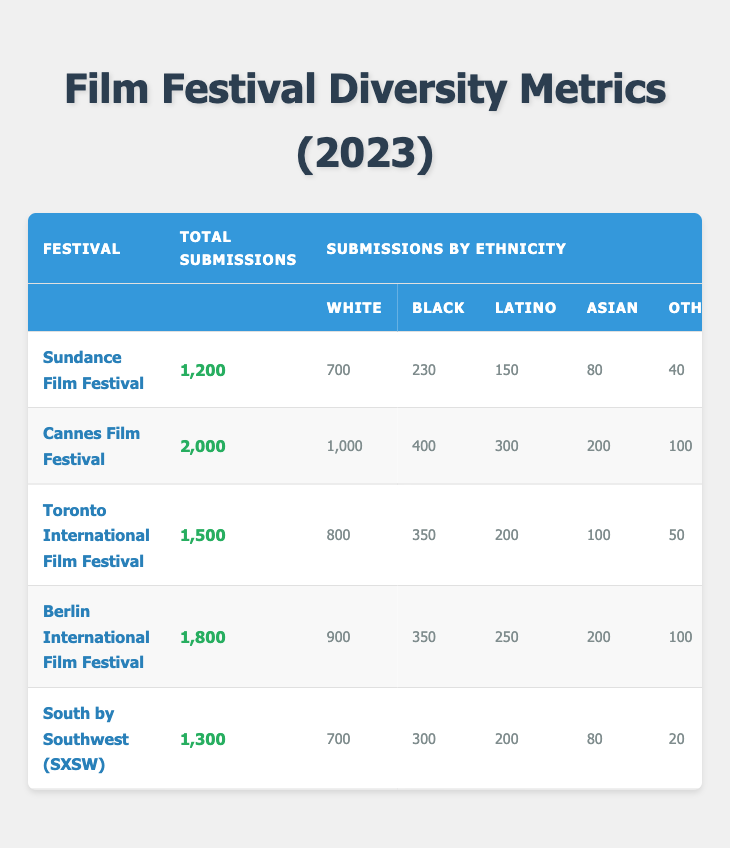What is the total number of submissions at the Cannes Film Festival? The Cannes Film Festival has 2,000 total submissions listed in the table.
Answer: 2,000 How many awards were given to Latino filmmakers at the Sundance Film Festival? The Sundance Film Festival awarded 2 Latino filmmakers based on the data.
Answer: 2 Which festival had the highest number of submissions by Asian filmmakers? At the Cannes Film Festival, 200 submissions were made by Asian filmmakers, which is the highest among all festivals listed.
Answer: Cannes Film Festival What is the total number of awards given across all festivals for Black filmmakers? To find the total awards for Black filmmakers, add up the awards: 3 (Sundance) + 4 (Cannes) + 5 (Toronto) + 4 (Berlin) + 2 (SXSW) = 18.
Answer: 18 Which festival had the least number of submissions by White filmmakers? The festival with the least submissions by White filmmakers is the SXSW with 700 submissions.
Answer: SXSW What percentage of total submissions at the Toronto International Film Festival were by Black filmmakers? To find the percentage, divide the number of submissions by Black filmmakers (350) by the total submissions (1,500), then multiply by 100: (350/1500) * 100 = 23.33%.
Answer: 23.33% Is it true that the Berlin International Film Festival had more awards for Latino filmmakers than SXSW? The Berlin International Film Festival awarded 3 Latino filmmakers while SXSW awarded 1, so the statement is true.
Answer: True What is the average number of awards given to White filmmakers across all festivals? To get the average, sum the awards for White filmmakers: 5 (Sundance) + 8 (Cannes) + 7 (Toronto) + 6 (Berlin) + 6 (SXSW) = 32. Then divide by the number of festivals (5): 32/5 = 6.4.
Answer: 6.4 How many total submissions were made by filmmakers of ethnicities other than White, Black, Latino, or Asian at the Sundance Film Festival? The total number of submissions made by Other filmmakers at Sundance is 40, which is given in the data.
Answer: 40 What is the difference in the number of awards given to Black filmmakers at the Cannes Film Festival compared to the Toronto International Film Festival? Cannes awarded 4 Black filmmakers and Toronto awarded 5, so the difference is 5 - 4 = 1 award.
Answer: 1 